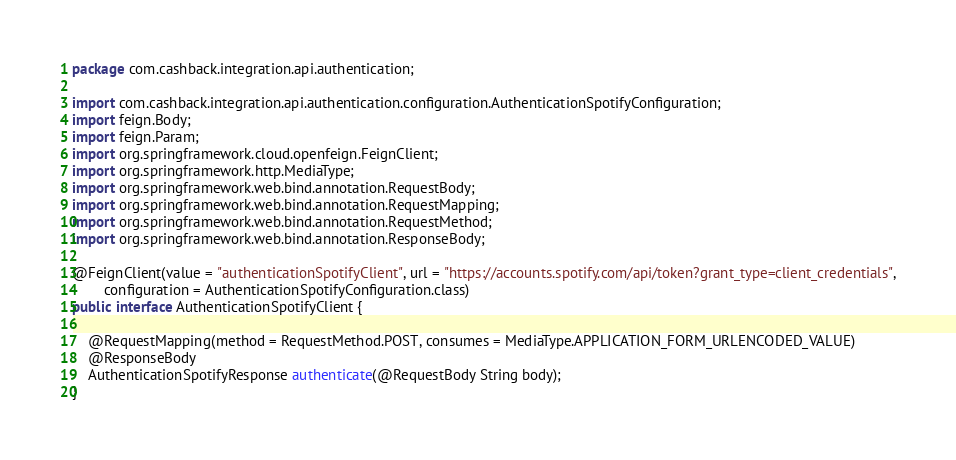<code> <loc_0><loc_0><loc_500><loc_500><_Java_>package com.cashback.integration.api.authentication;

import com.cashback.integration.api.authentication.configuration.AuthenticationSpotifyConfiguration;
import feign.Body;
import feign.Param;
import org.springframework.cloud.openfeign.FeignClient;
import org.springframework.http.MediaType;
import org.springframework.web.bind.annotation.RequestBody;
import org.springframework.web.bind.annotation.RequestMapping;
import org.springframework.web.bind.annotation.RequestMethod;
import org.springframework.web.bind.annotation.ResponseBody;

@FeignClient(value = "authenticationSpotifyClient", url = "https://accounts.spotify.com/api/token?grant_type=client_credentials",
        configuration = AuthenticationSpotifyConfiguration.class)
public interface AuthenticationSpotifyClient {

    @RequestMapping(method = RequestMethod.POST, consumes = MediaType.APPLICATION_FORM_URLENCODED_VALUE)
    @ResponseBody
    AuthenticationSpotifyResponse authenticate(@RequestBody String body);
}

</code> 